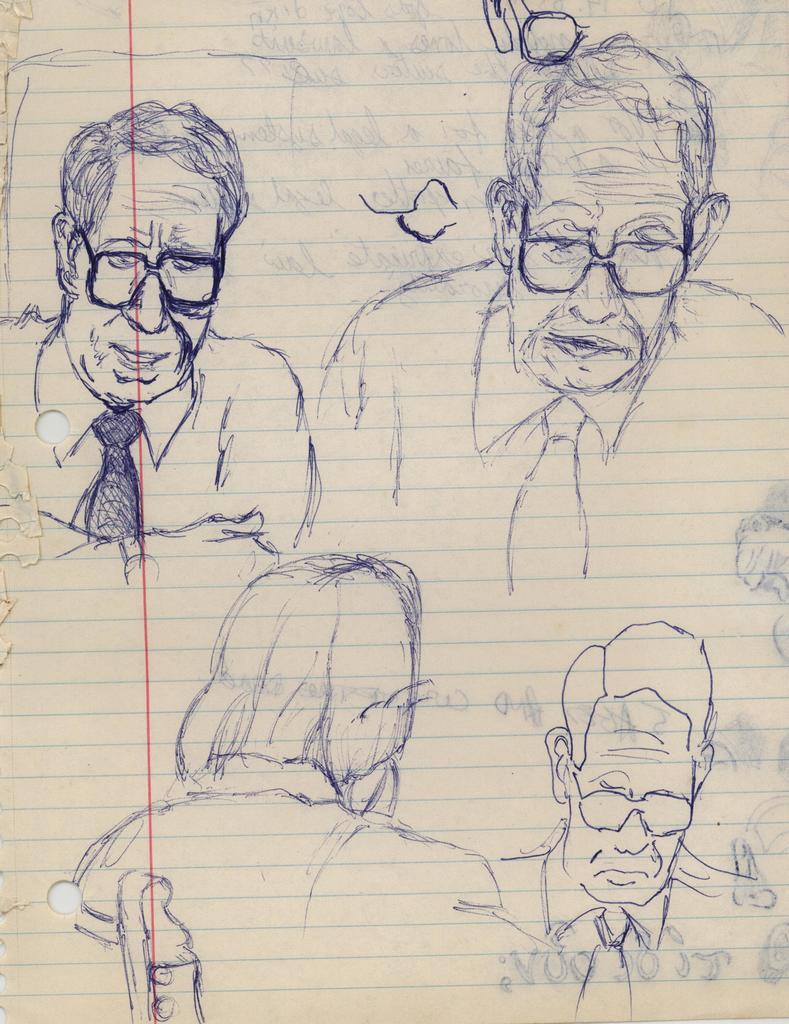What is present on the paper in the image? There is a drawing on the paper in the image. What does the drawing depict? The drawing depicts a few people. What type of bells can be heard ringing in the image? There are no bells present in the image, and therefore no sound can be heard. 